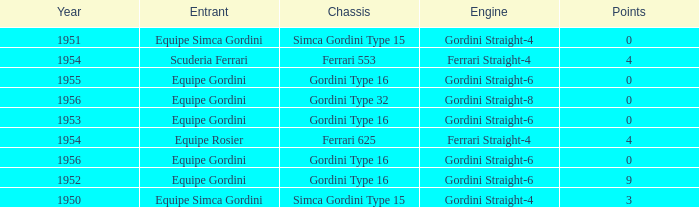How many points after 1956? 0.0. 